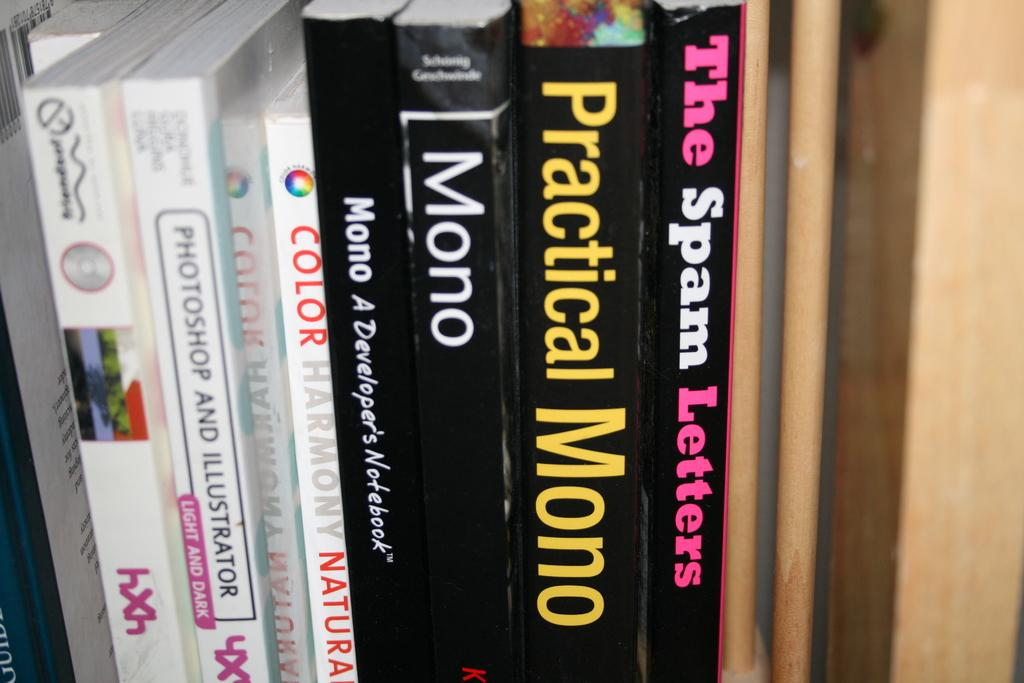<image>
Summarize the visual content of the image. Three books on Mono programming are sandwiched between other books. 